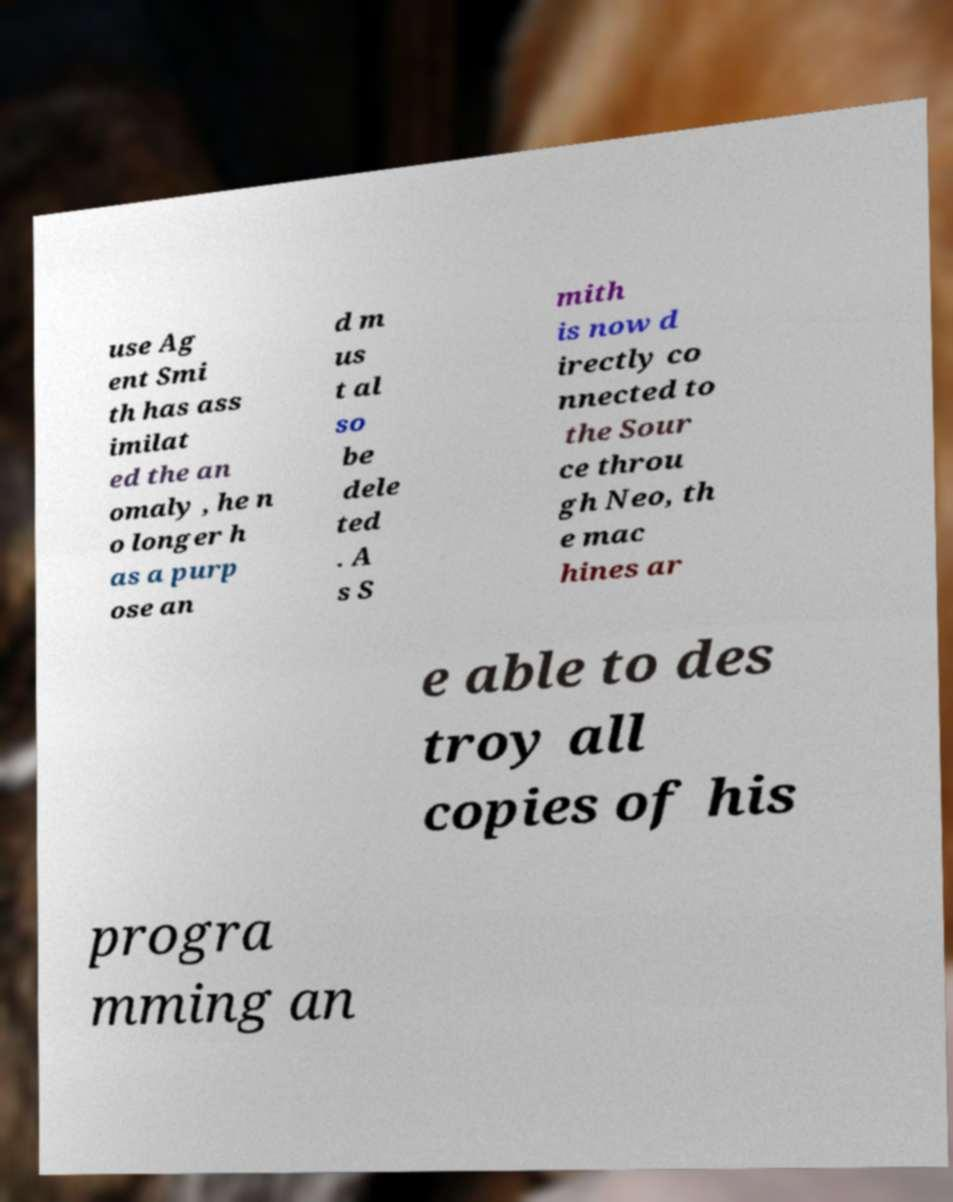For documentation purposes, I need the text within this image transcribed. Could you provide that? use Ag ent Smi th has ass imilat ed the an omaly , he n o longer h as a purp ose an d m us t al so be dele ted . A s S mith is now d irectly co nnected to the Sour ce throu gh Neo, th e mac hines ar e able to des troy all copies of his progra mming an 